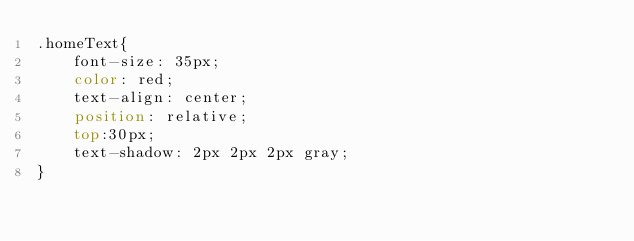Convert code to text. <code><loc_0><loc_0><loc_500><loc_500><_CSS_>.homeText{
    font-size: 35px;
    color: red;
    text-align: center;
    position: relative;
    top:30px;
    text-shadow: 2px 2px 2px gray;
}</code> 